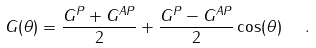<formula> <loc_0><loc_0><loc_500><loc_500>G ( \theta ) = \frac { G ^ { P } + G ^ { A P } } { 2 } + \frac { G ^ { P } - G ^ { A P } } { 2 } \cos ( \theta ) \ \ .</formula> 